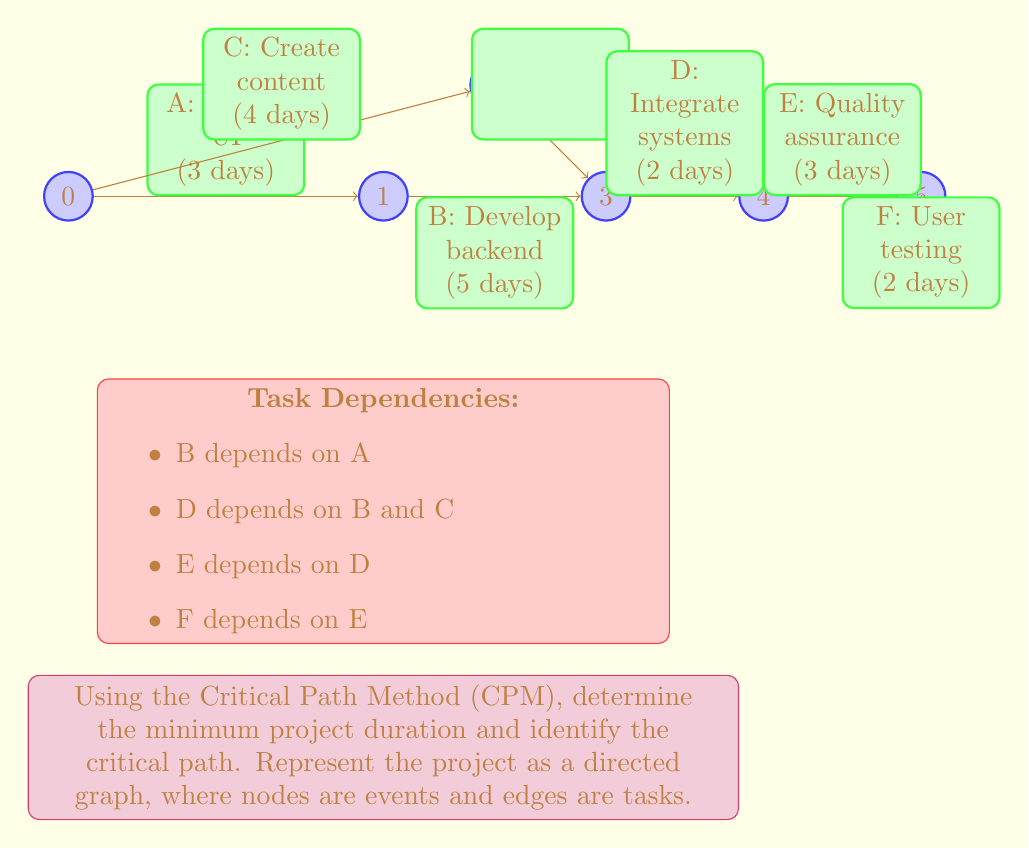Can you solve this math problem? Let's solve this step-by-step using the Critical Path Method:

1. Create the network diagram:
   The diagram is shown in the question. Nodes represent events, and edges represent tasks with their durations.

2. Calculate the earliest start time (EST) for each event:
   - Event 0 (Start): EST = 0
   - Event 1 (After A): EST = 0 + 3 = 3
   - Event 2 (After C): EST = 0 + 4 = 4
   - Event 3 (After B and C): EST = max(3 + 5, 4) = 8
   - Event 4 (After D): EST = 8 + 2 = 10
   - Event 5 (After E and F): EST = 10 + 3 + 2 = 15

3. Calculate the latest finish time (LFT) for each event:
   - Event 5 (End): LFT = 15
   - Event 4: LFT = 15 - 2 = 13
   - Event 3: LFT = 13 - 3 = 10
   - Event 2: LFT = 10 - 0 = 10
   - Event 1: LFT = 8 - 5 = 3
   - Event 0: LFT = 3 - 3 = 0

4. Calculate the slack for each task:
   Slack = LFT - EST - Duration
   - A: 3 - 0 - 3 = 0
   - B: 8 - 3 - 5 = 0
   - C: 10 - 0 - 4 = 6
   - D: 10 - 8 - 2 = 0
   - E: 13 - 10 - 3 = 0
   - F: 15 - 13 - 2 = 0

5. Identify the critical path:
   The critical path consists of tasks with zero slack: A -> B -> D -> E -> F

6. Calculate the minimum project duration:
   The minimum duration is the sum of durations along the critical path:
   3 + 5 + 2 + 3 + 2 = 15 days
Answer: Minimum project duration: 15 days
Critical path: A -> B -> D -> E -> F 